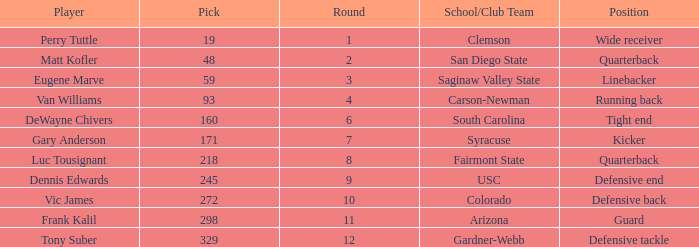Which Round has a School/Club Team of arizona, and a Pick smaller than 298? None. 